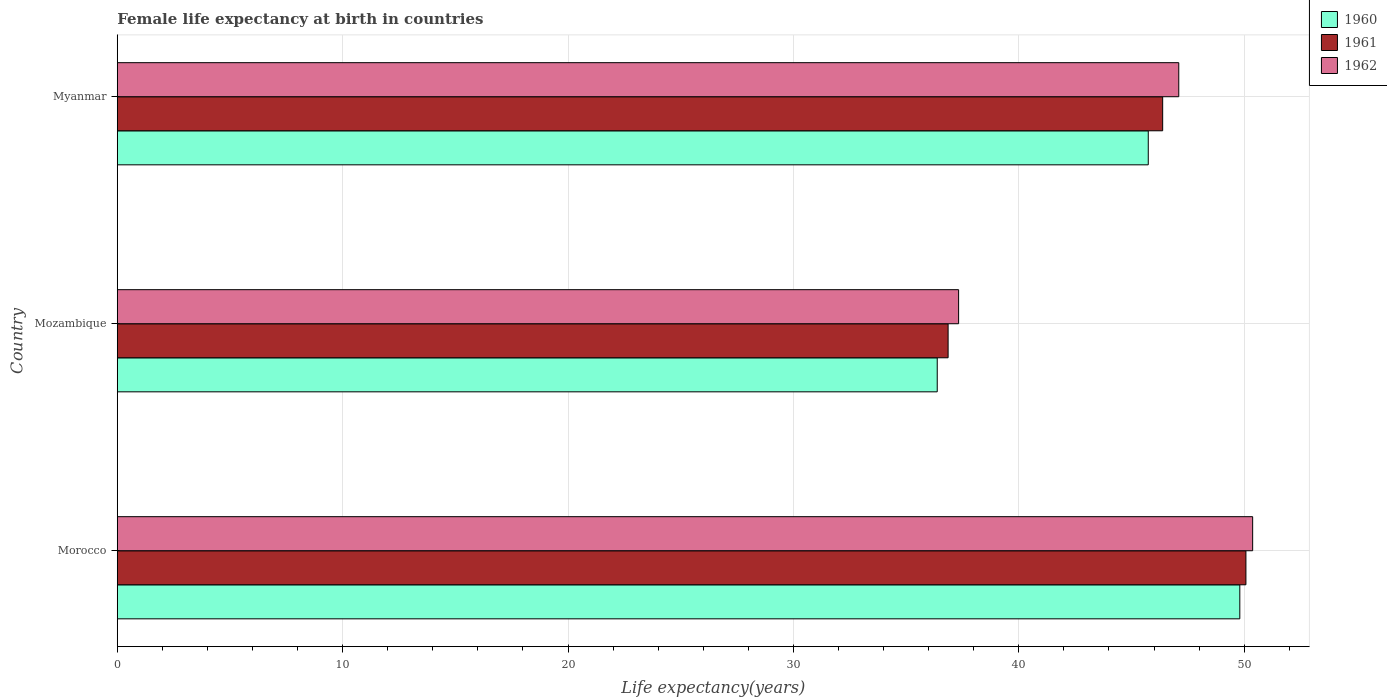How many bars are there on the 1st tick from the top?
Offer a very short reply. 3. What is the label of the 1st group of bars from the top?
Provide a succinct answer. Myanmar. In how many cases, is the number of bars for a given country not equal to the number of legend labels?
Provide a succinct answer. 0. What is the female life expectancy at birth in 1960 in Mozambique?
Ensure brevity in your answer.  36.38. Across all countries, what is the maximum female life expectancy at birth in 1960?
Offer a very short reply. 49.81. Across all countries, what is the minimum female life expectancy at birth in 1961?
Provide a succinct answer. 36.86. In which country was the female life expectancy at birth in 1962 maximum?
Provide a succinct answer. Morocco. In which country was the female life expectancy at birth in 1960 minimum?
Give a very brief answer. Mozambique. What is the total female life expectancy at birth in 1961 in the graph?
Your response must be concise. 133.32. What is the difference between the female life expectancy at birth in 1961 in Morocco and that in Mozambique?
Make the answer very short. 13.21. What is the difference between the female life expectancy at birth in 1962 in Myanmar and the female life expectancy at birth in 1960 in Mozambique?
Offer a terse response. 10.72. What is the average female life expectancy at birth in 1962 per country?
Keep it short and to the point. 44.93. What is the difference between the female life expectancy at birth in 1961 and female life expectancy at birth in 1960 in Morocco?
Provide a short and direct response. 0.27. What is the ratio of the female life expectancy at birth in 1962 in Morocco to that in Mozambique?
Your response must be concise. 1.35. What is the difference between the highest and the second highest female life expectancy at birth in 1961?
Your answer should be compact. 3.69. What is the difference between the highest and the lowest female life expectancy at birth in 1960?
Offer a very short reply. 13.42. Is the sum of the female life expectancy at birth in 1961 in Mozambique and Myanmar greater than the maximum female life expectancy at birth in 1960 across all countries?
Give a very brief answer. Yes. What does the 3rd bar from the bottom in Mozambique represents?
Ensure brevity in your answer.  1962. Are all the bars in the graph horizontal?
Give a very brief answer. Yes. Does the graph contain any zero values?
Your response must be concise. No. What is the title of the graph?
Make the answer very short. Female life expectancy at birth in countries. Does "2009" appear as one of the legend labels in the graph?
Offer a very short reply. No. What is the label or title of the X-axis?
Your answer should be compact. Life expectancy(years). What is the Life expectancy(years) of 1960 in Morocco?
Your response must be concise. 49.81. What is the Life expectancy(years) of 1961 in Morocco?
Make the answer very short. 50.08. What is the Life expectancy(years) in 1962 in Morocco?
Your answer should be compact. 50.38. What is the Life expectancy(years) of 1960 in Mozambique?
Offer a very short reply. 36.38. What is the Life expectancy(years) in 1961 in Mozambique?
Provide a succinct answer. 36.86. What is the Life expectancy(years) of 1962 in Mozambique?
Your answer should be very brief. 37.33. What is the Life expectancy(years) in 1960 in Myanmar?
Your answer should be very brief. 45.74. What is the Life expectancy(years) in 1961 in Myanmar?
Keep it short and to the point. 46.38. What is the Life expectancy(years) of 1962 in Myanmar?
Make the answer very short. 47.1. Across all countries, what is the maximum Life expectancy(years) in 1960?
Your answer should be very brief. 49.81. Across all countries, what is the maximum Life expectancy(years) of 1961?
Provide a succinct answer. 50.08. Across all countries, what is the maximum Life expectancy(years) of 1962?
Your answer should be compact. 50.38. Across all countries, what is the minimum Life expectancy(years) in 1960?
Provide a succinct answer. 36.38. Across all countries, what is the minimum Life expectancy(years) in 1961?
Ensure brevity in your answer.  36.86. Across all countries, what is the minimum Life expectancy(years) in 1962?
Make the answer very short. 37.33. What is the total Life expectancy(years) of 1960 in the graph?
Your answer should be compact. 131.93. What is the total Life expectancy(years) of 1961 in the graph?
Offer a terse response. 133.32. What is the total Life expectancy(years) in 1962 in the graph?
Keep it short and to the point. 134.8. What is the difference between the Life expectancy(years) of 1960 in Morocco and that in Mozambique?
Make the answer very short. 13.43. What is the difference between the Life expectancy(years) in 1961 in Morocco and that in Mozambique?
Offer a very short reply. 13.21. What is the difference between the Life expectancy(years) in 1962 in Morocco and that in Mozambique?
Give a very brief answer. 13.05. What is the difference between the Life expectancy(years) in 1960 in Morocco and that in Myanmar?
Provide a short and direct response. 4.06. What is the difference between the Life expectancy(years) in 1961 in Morocco and that in Myanmar?
Make the answer very short. 3.69. What is the difference between the Life expectancy(years) of 1962 in Morocco and that in Myanmar?
Offer a very short reply. 3.28. What is the difference between the Life expectancy(years) of 1960 in Mozambique and that in Myanmar?
Offer a terse response. -9.36. What is the difference between the Life expectancy(years) in 1961 in Mozambique and that in Myanmar?
Your answer should be compact. -9.52. What is the difference between the Life expectancy(years) in 1962 in Mozambique and that in Myanmar?
Keep it short and to the point. -9.77. What is the difference between the Life expectancy(years) of 1960 in Morocco and the Life expectancy(years) of 1961 in Mozambique?
Make the answer very short. 12.94. What is the difference between the Life expectancy(years) in 1960 in Morocco and the Life expectancy(years) in 1962 in Mozambique?
Keep it short and to the point. 12.48. What is the difference between the Life expectancy(years) of 1961 in Morocco and the Life expectancy(years) of 1962 in Mozambique?
Your answer should be very brief. 12.75. What is the difference between the Life expectancy(years) in 1960 in Morocco and the Life expectancy(years) in 1961 in Myanmar?
Ensure brevity in your answer.  3.42. What is the difference between the Life expectancy(years) of 1960 in Morocco and the Life expectancy(years) of 1962 in Myanmar?
Your response must be concise. 2.71. What is the difference between the Life expectancy(years) in 1961 in Morocco and the Life expectancy(years) in 1962 in Myanmar?
Ensure brevity in your answer.  2.98. What is the difference between the Life expectancy(years) of 1960 in Mozambique and the Life expectancy(years) of 1961 in Myanmar?
Make the answer very short. -10. What is the difference between the Life expectancy(years) in 1960 in Mozambique and the Life expectancy(years) in 1962 in Myanmar?
Give a very brief answer. -10.72. What is the difference between the Life expectancy(years) of 1961 in Mozambique and the Life expectancy(years) of 1962 in Myanmar?
Make the answer very short. -10.23. What is the average Life expectancy(years) in 1960 per country?
Provide a succinct answer. 43.98. What is the average Life expectancy(years) of 1961 per country?
Ensure brevity in your answer.  44.44. What is the average Life expectancy(years) in 1962 per country?
Keep it short and to the point. 44.93. What is the difference between the Life expectancy(years) of 1960 and Life expectancy(years) of 1961 in Morocco?
Your answer should be very brief. -0.27. What is the difference between the Life expectancy(years) of 1960 and Life expectancy(years) of 1962 in Morocco?
Make the answer very short. -0.57. What is the difference between the Life expectancy(years) of 1961 and Life expectancy(years) of 1962 in Morocco?
Provide a succinct answer. -0.3. What is the difference between the Life expectancy(years) of 1960 and Life expectancy(years) of 1961 in Mozambique?
Provide a short and direct response. -0.48. What is the difference between the Life expectancy(years) of 1960 and Life expectancy(years) of 1962 in Mozambique?
Keep it short and to the point. -0.95. What is the difference between the Life expectancy(years) of 1961 and Life expectancy(years) of 1962 in Mozambique?
Your response must be concise. -0.47. What is the difference between the Life expectancy(years) in 1960 and Life expectancy(years) in 1961 in Myanmar?
Give a very brief answer. -0.64. What is the difference between the Life expectancy(years) in 1960 and Life expectancy(years) in 1962 in Myanmar?
Make the answer very short. -1.35. What is the difference between the Life expectancy(years) of 1961 and Life expectancy(years) of 1962 in Myanmar?
Provide a succinct answer. -0.71. What is the ratio of the Life expectancy(years) of 1960 in Morocco to that in Mozambique?
Provide a short and direct response. 1.37. What is the ratio of the Life expectancy(years) in 1961 in Morocco to that in Mozambique?
Make the answer very short. 1.36. What is the ratio of the Life expectancy(years) in 1962 in Morocco to that in Mozambique?
Keep it short and to the point. 1.35. What is the ratio of the Life expectancy(years) in 1960 in Morocco to that in Myanmar?
Make the answer very short. 1.09. What is the ratio of the Life expectancy(years) of 1961 in Morocco to that in Myanmar?
Provide a short and direct response. 1.08. What is the ratio of the Life expectancy(years) in 1962 in Morocco to that in Myanmar?
Your response must be concise. 1.07. What is the ratio of the Life expectancy(years) in 1960 in Mozambique to that in Myanmar?
Give a very brief answer. 0.8. What is the ratio of the Life expectancy(years) of 1961 in Mozambique to that in Myanmar?
Give a very brief answer. 0.79. What is the ratio of the Life expectancy(years) in 1962 in Mozambique to that in Myanmar?
Give a very brief answer. 0.79. What is the difference between the highest and the second highest Life expectancy(years) of 1960?
Offer a very short reply. 4.06. What is the difference between the highest and the second highest Life expectancy(years) of 1961?
Your answer should be compact. 3.69. What is the difference between the highest and the second highest Life expectancy(years) in 1962?
Your answer should be very brief. 3.28. What is the difference between the highest and the lowest Life expectancy(years) of 1960?
Offer a very short reply. 13.43. What is the difference between the highest and the lowest Life expectancy(years) in 1961?
Ensure brevity in your answer.  13.21. What is the difference between the highest and the lowest Life expectancy(years) of 1962?
Provide a short and direct response. 13.05. 